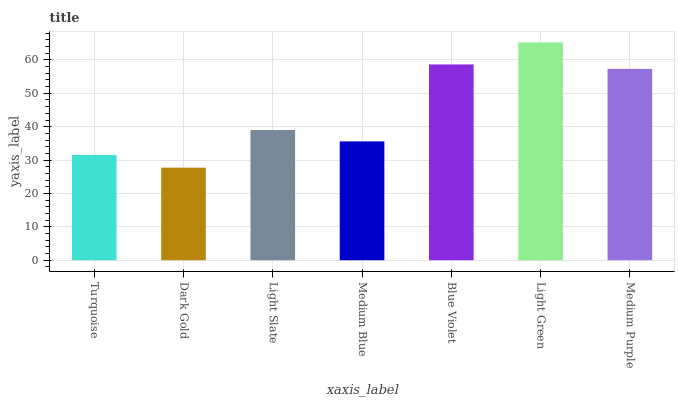Is Light Slate the minimum?
Answer yes or no. No. Is Light Slate the maximum?
Answer yes or no. No. Is Light Slate greater than Dark Gold?
Answer yes or no. Yes. Is Dark Gold less than Light Slate?
Answer yes or no. Yes. Is Dark Gold greater than Light Slate?
Answer yes or no. No. Is Light Slate less than Dark Gold?
Answer yes or no. No. Is Light Slate the high median?
Answer yes or no. Yes. Is Light Slate the low median?
Answer yes or no. Yes. Is Turquoise the high median?
Answer yes or no. No. Is Light Green the low median?
Answer yes or no. No. 